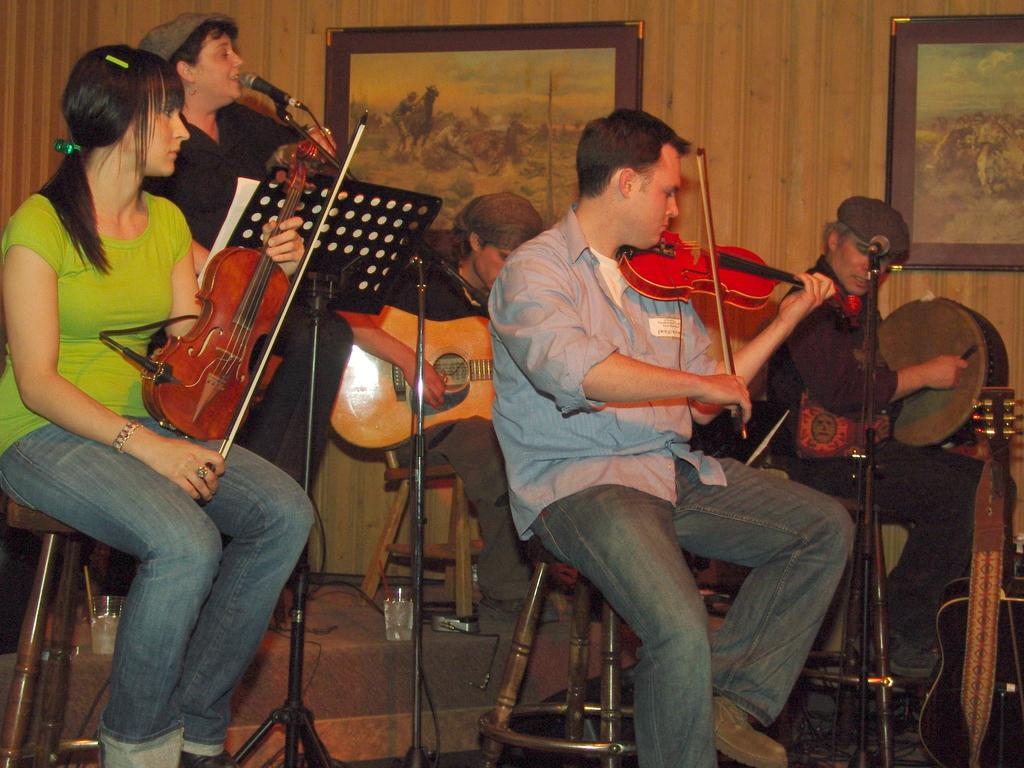Who or what can be seen in the image? There are people in the image. What are the people doing in the image? The people are sitting on chairs and playing musical instruments. Where is the store located in the image? There is no store present in the image; it features people sitting on chairs and playing musical instruments. What type of writer can be seen in the image? There is no writer present in the image; it features people sitting on chairs and playing musical instruments. 